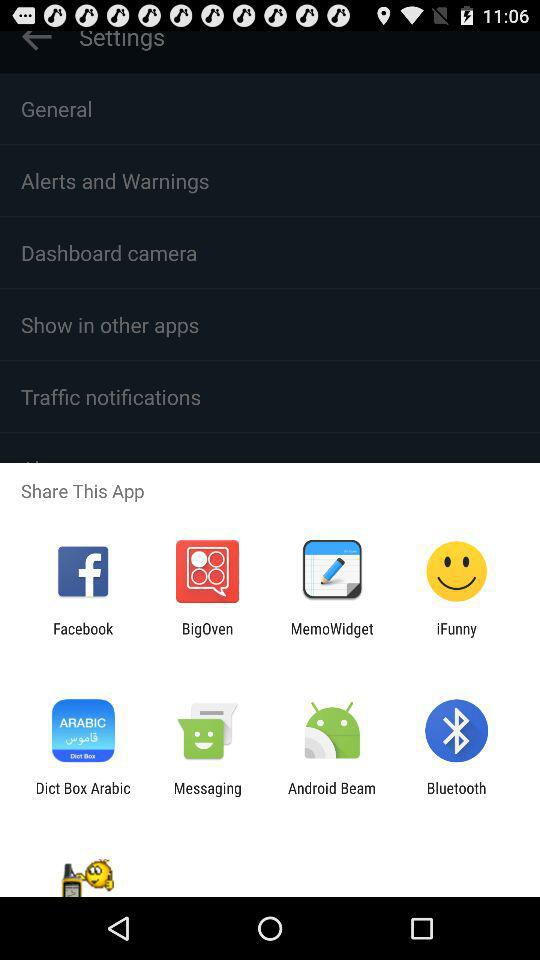Through what app can I share? The sharing options are "Facebook", "BigOven", "MemoWidget", "iFunny", "Dict Box Arabic", "Messaging", "Android Beam" and "Bluetooth". 